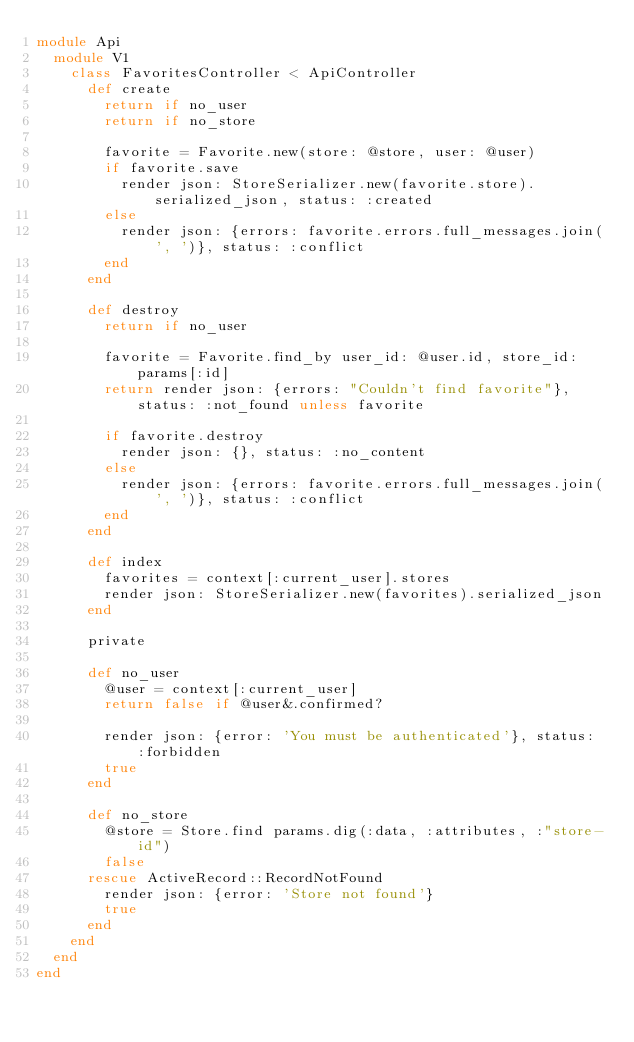Convert code to text. <code><loc_0><loc_0><loc_500><loc_500><_Ruby_>module Api
  module V1
    class FavoritesController < ApiController
      def create
        return if no_user
        return if no_store

        favorite = Favorite.new(store: @store, user: @user)
        if favorite.save
          render json: StoreSerializer.new(favorite.store).serialized_json, status: :created
        else
          render json: {errors: favorite.errors.full_messages.join(', ')}, status: :conflict
        end
      end

      def destroy
        return if no_user

        favorite = Favorite.find_by user_id: @user.id, store_id: params[:id]
        return render json: {errors: "Couldn't find favorite"}, status: :not_found unless favorite

        if favorite.destroy
          render json: {}, status: :no_content
        else
          render json: {errors: favorite.errors.full_messages.join(', ')}, status: :conflict
        end
      end

      def index
        favorites = context[:current_user].stores
        render json: StoreSerializer.new(favorites).serialized_json
      end

      private

      def no_user
        @user = context[:current_user]
        return false if @user&.confirmed?

        render json: {error: 'You must be authenticated'}, status: :forbidden
        true
      end

      def no_store
        @store = Store.find params.dig(:data, :attributes, :"store-id")
        false
      rescue ActiveRecord::RecordNotFound
        render json: {error: 'Store not found'}
        true
      end
    end
  end
end
</code> 